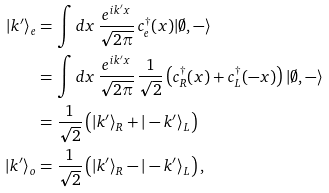Convert formula to latex. <formula><loc_0><loc_0><loc_500><loc_500>| k ^ { \prime } \rangle _ { e } & = \int d x \, \frac { e ^ { i k ^ { \prime } x } } { \sqrt { 2 \pi } } \, c ^ { \dagger } _ { e } ( x ) | \emptyset , - \rangle \\ & = \int d x \, \frac { e ^ { i k ^ { \prime } x } } { \sqrt { 2 \pi } } \, \frac { 1 } { \sqrt { 2 } } \left ( c ^ { \dagger } _ { R } ( x ) + c ^ { \dagger } _ { L } ( - x ) \right ) | \emptyset , - \rangle \\ & = \frac { 1 } { \sqrt { 2 } } \left ( | k ^ { \prime } \rangle _ { R } + | - k ^ { \prime } \rangle _ { L } \right ) \\ | k ^ { \prime } \rangle _ { o } & = \frac { 1 } { \sqrt { 2 } } \left ( | k ^ { \prime } \rangle _ { R } - | - k ^ { \prime } \rangle _ { L } \right ) ,</formula> 